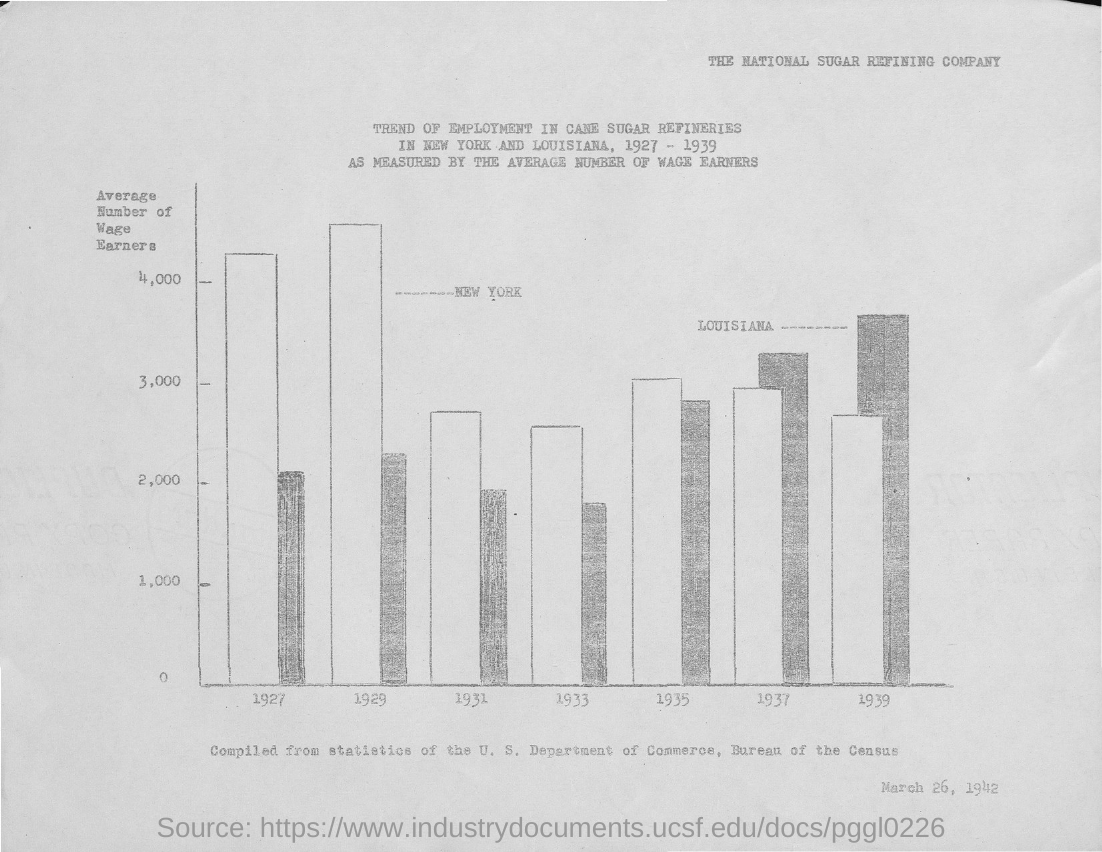Identify some key points in this picture. The average number of wage earners is plotted on the y-axis. The date mentioned at the bottom of the document is March 26, 1942. The National Sugar Refining Company is the name of the company. 